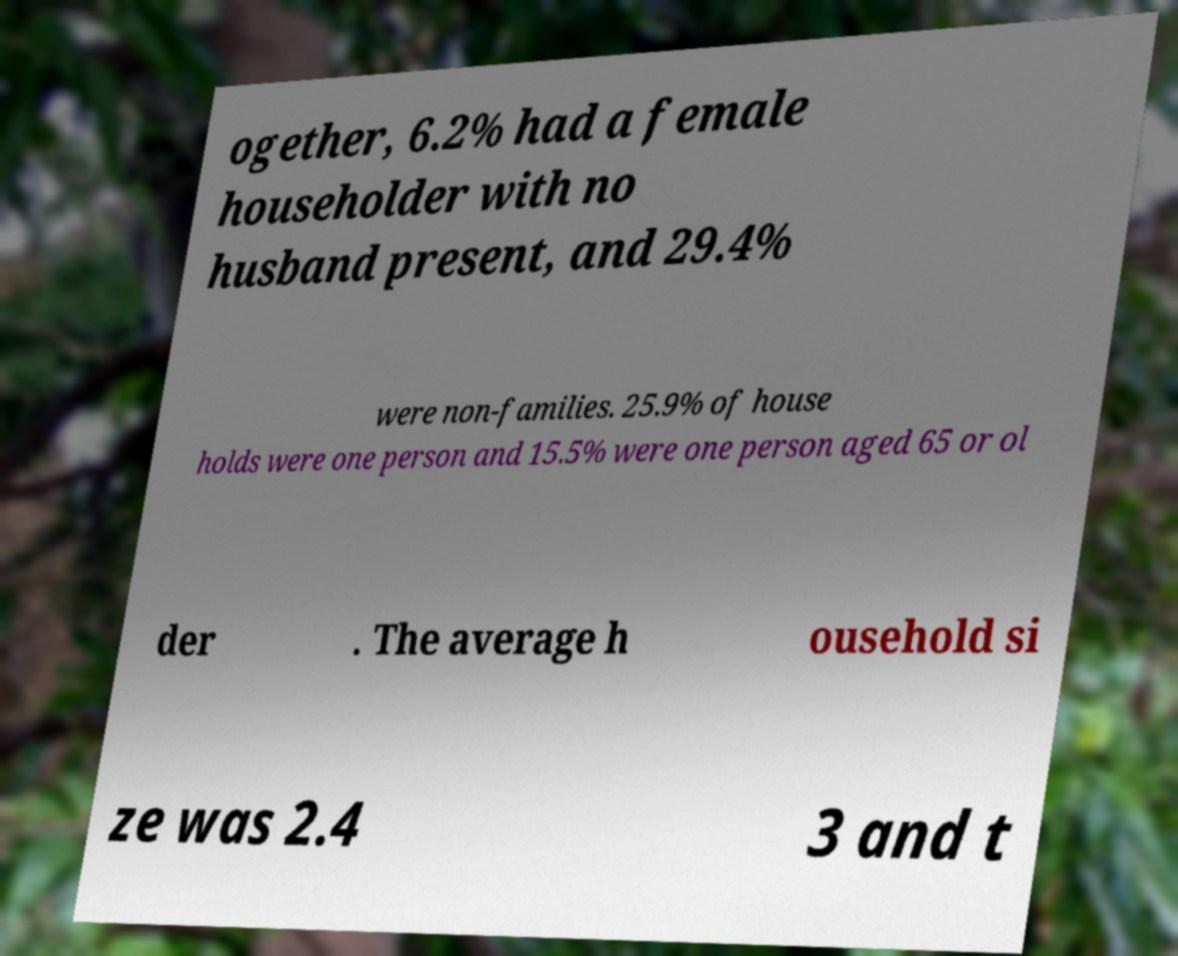Please identify and transcribe the text found in this image. ogether, 6.2% had a female householder with no husband present, and 29.4% were non-families. 25.9% of house holds were one person and 15.5% were one person aged 65 or ol der . The average h ousehold si ze was 2.4 3 and t 